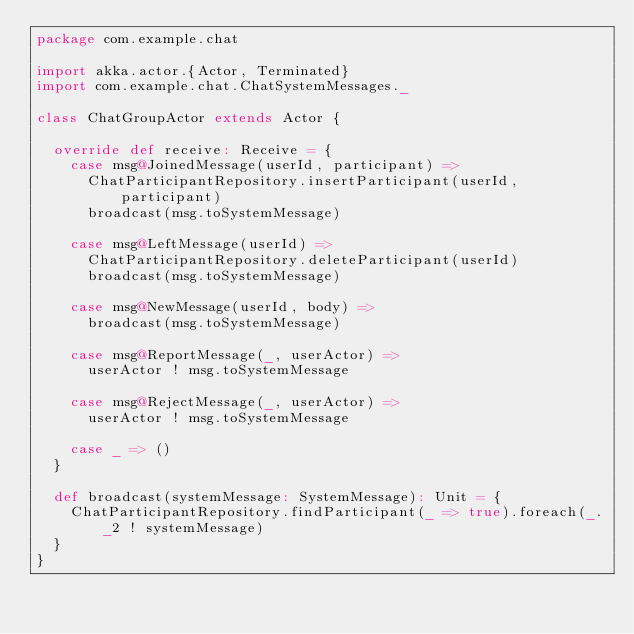Convert code to text. <code><loc_0><loc_0><loc_500><loc_500><_Scala_>package com.example.chat

import akka.actor.{Actor, Terminated}
import com.example.chat.ChatSystemMessages._

class ChatGroupActor extends Actor {

  override def receive: Receive = {
    case msg@JoinedMessage(userId, participant) =>
      ChatParticipantRepository.insertParticipant(userId, participant)
      broadcast(msg.toSystemMessage)

    case msg@LeftMessage(userId) =>
      ChatParticipantRepository.deleteParticipant(userId)
      broadcast(msg.toSystemMessage)

    case msg@NewMessage(userId, body) =>
      broadcast(msg.toSystemMessage)

    case msg@ReportMessage(_, userActor) =>
      userActor ! msg.toSystemMessage

    case msg@RejectMessage(_, userActor) =>
      userActor ! msg.toSystemMessage

    case _ => ()
  }

  def broadcast(systemMessage: SystemMessage): Unit = {
    ChatParticipantRepository.findParticipant(_ => true).foreach(_._2 ! systemMessage)
  }
}
</code> 